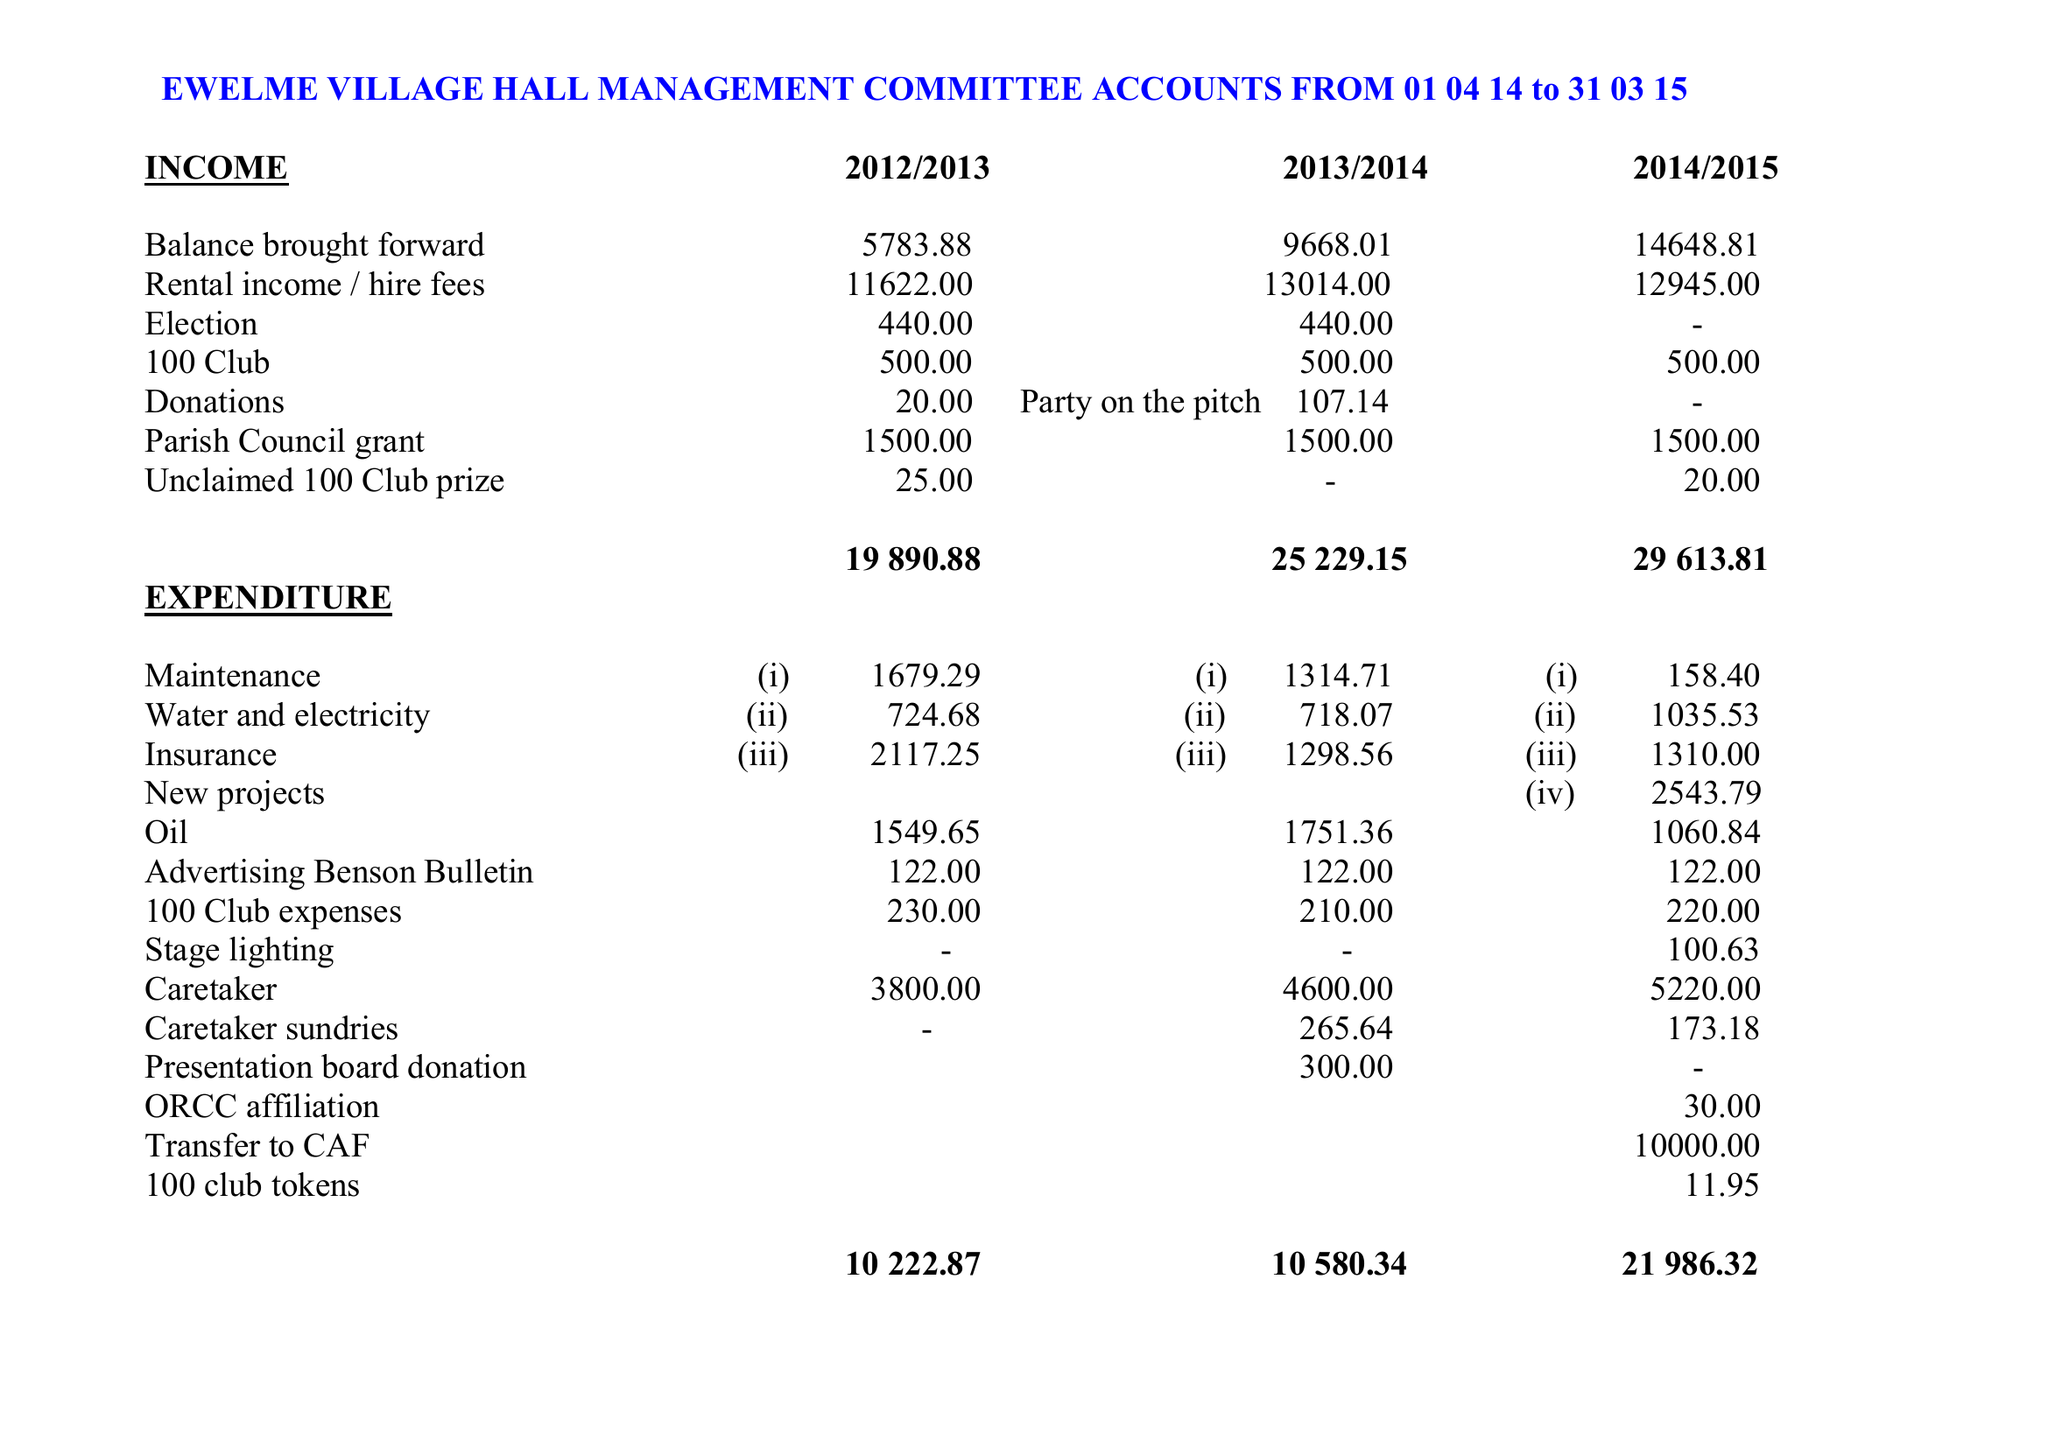What is the value for the address__street_line?
Answer the question using a single word or phrase. 7 CHAUCER COURT 